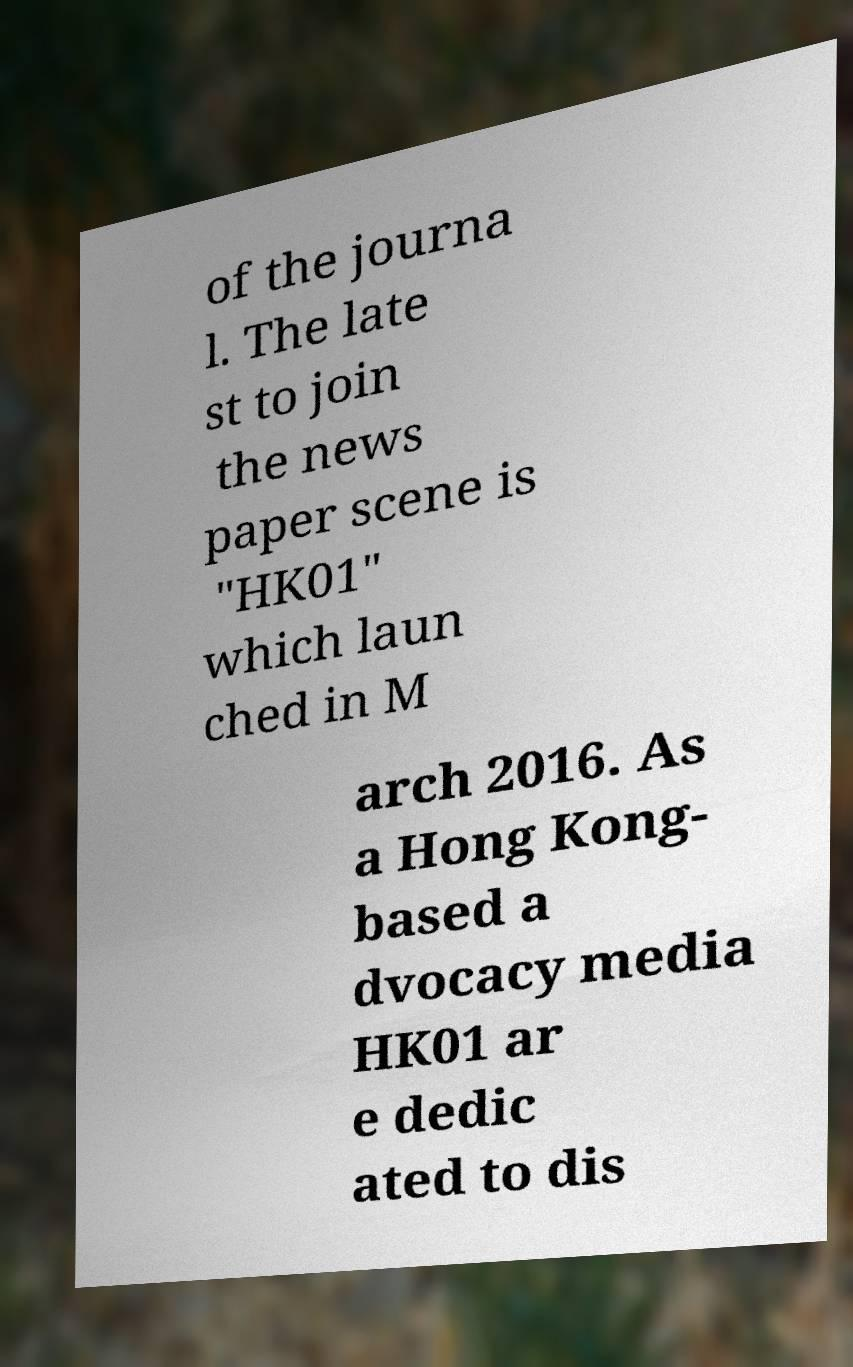What messages or text are displayed in this image? I need them in a readable, typed format. of the journa l. The late st to join the news paper scene is "HK01" which laun ched in M arch 2016. As a Hong Kong- based a dvocacy media HK01 ar e dedic ated to dis 